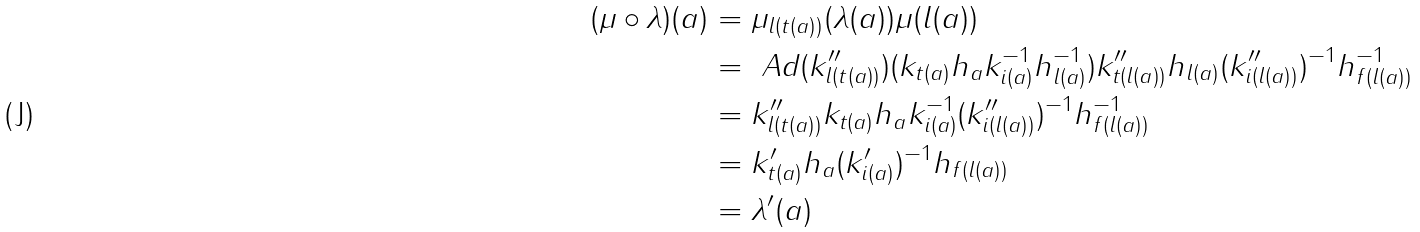Convert formula to latex. <formula><loc_0><loc_0><loc_500><loc_500>( \mu \circ \lambda ) ( a ) & = \mu _ { l ( t ( a ) ) } ( \lambda ( a ) ) \mu ( l ( a ) ) \\ & = \ A d ( k _ { l ( t ( a ) ) } ^ { \prime \prime } ) ( k _ { t ( a ) } h _ { a } k _ { i ( a ) } ^ { - 1 } h _ { l ( a ) } ^ { - 1 } ) k _ { t ( l ( a ) ) } ^ { \prime \prime } h _ { l ( a ) } ( k _ { i ( l ( a ) ) } ^ { \prime \prime } ) ^ { - 1 } h _ { f ( l ( a ) ) } ^ { - 1 } \\ & = k _ { l ( t ( a ) ) } ^ { \prime \prime } k _ { t ( a ) } h _ { a } k _ { i ( a ) } ^ { - 1 } ( k _ { i ( l ( a ) ) } ^ { \prime \prime } ) ^ { - 1 } h _ { f ( l ( a ) ) } ^ { - 1 } \\ & = k ^ { \prime } _ { t ( a ) } h _ { a } ( k _ { i ( a ) } ^ { \prime } ) ^ { - 1 } h _ { f ( l ( a ) ) } \\ & = \lambda ^ { \prime } ( a )</formula> 